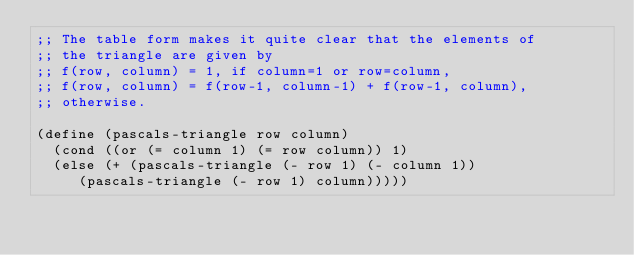<code> <loc_0><loc_0><loc_500><loc_500><_Scheme_>;; The table form makes it quite clear that the elements of
;; the triangle are given by
;; f(row, column) = 1, if column=1 or row=column,
;; f(row, column) = f(row-1, column-1) + f(row-1, column),
;; otherwise.

(define (pascals-triangle row column)
  (cond ((or (= column 1) (= row column)) 1)
	(else (+ (pascals-triangle (- row 1) (- column 1))
		 (pascals-triangle (- row 1) column)))))
</code> 